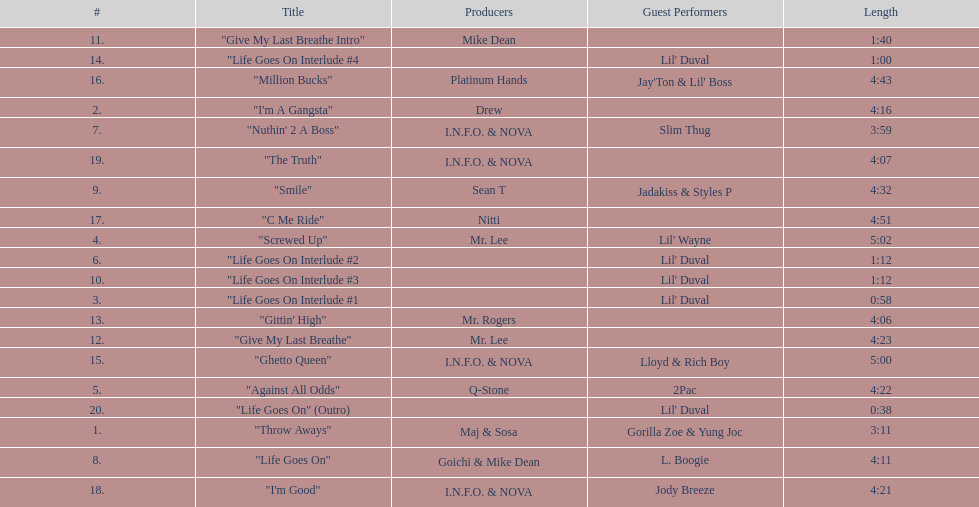What is the first track featuring lil' duval? "Life Goes On Interlude #1. Can you give me this table as a dict? {'header': ['#', 'Title', 'Producers', 'Guest Performers', 'Length'], 'rows': [['11.', '"Give My Last Breathe Intro"', 'Mike Dean', '', '1:40'], ['14.', '"Life Goes On Interlude #4', '', "Lil' Duval", '1:00'], ['16.', '"Million Bucks"', 'Platinum Hands', "Jay'Ton & Lil' Boss", '4:43'], ['2.', '"I\'m A Gangsta"', 'Drew', '', '4:16'], ['7.', '"Nuthin\' 2 A Boss"', 'I.N.F.O. & NOVA', 'Slim Thug', '3:59'], ['19.', '"The Truth"', 'I.N.F.O. & NOVA', '', '4:07'], ['9.', '"Smile"', 'Sean T', 'Jadakiss & Styles P', '4:32'], ['17.', '"C Me Ride"', 'Nitti', '', '4:51'], ['4.', '"Screwed Up"', 'Mr. Lee', "Lil' Wayne", '5:02'], ['6.', '"Life Goes On Interlude #2', '', "Lil' Duval", '1:12'], ['10.', '"Life Goes On Interlude #3', '', "Lil' Duval", '1:12'], ['3.', '"Life Goes On Interlude #1', '', "Lil' Duval", '0:58'], ['13.', '"Gittin\' High"', 'Mr. Rogers', '', '4:06'], ['12.', '"Give My Last Breathe"', 'Mr. Lee', '', '4:23'], ['15.', '"Ghetto Queen"', 'I.N.F.O. & NOVA', 'Lloyd & Rich Boy', '5:00'], ['5.', '"Against All Odds"', 'Q-Stone', '2Pac', '4:22'], ['20.', '"Life Goes On" (Outro)', '', "Lil' Duval", '0:38'], ['1.', '"Throw Aways"', 'Maj & Sosa', 'Gorilla Zoe & Yung Joc', '3:11'], ['8.', '"Life Goes On"', 'Goichi & Mike Dean', 'L. Boogie', '4:11'], ['18.', '"I\'m Good"', 'I.N.F.O. & NOVA', 'Jody Breeze', '4:21']]} 